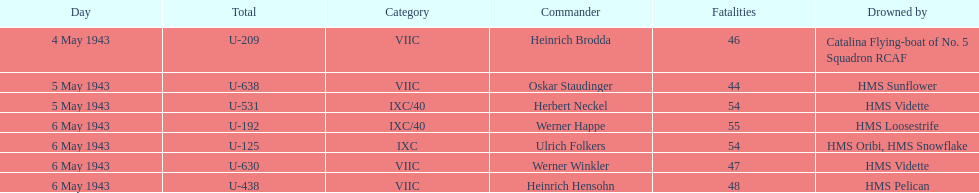How many more casualties occurred on may 6 compared to may 4? 158. 